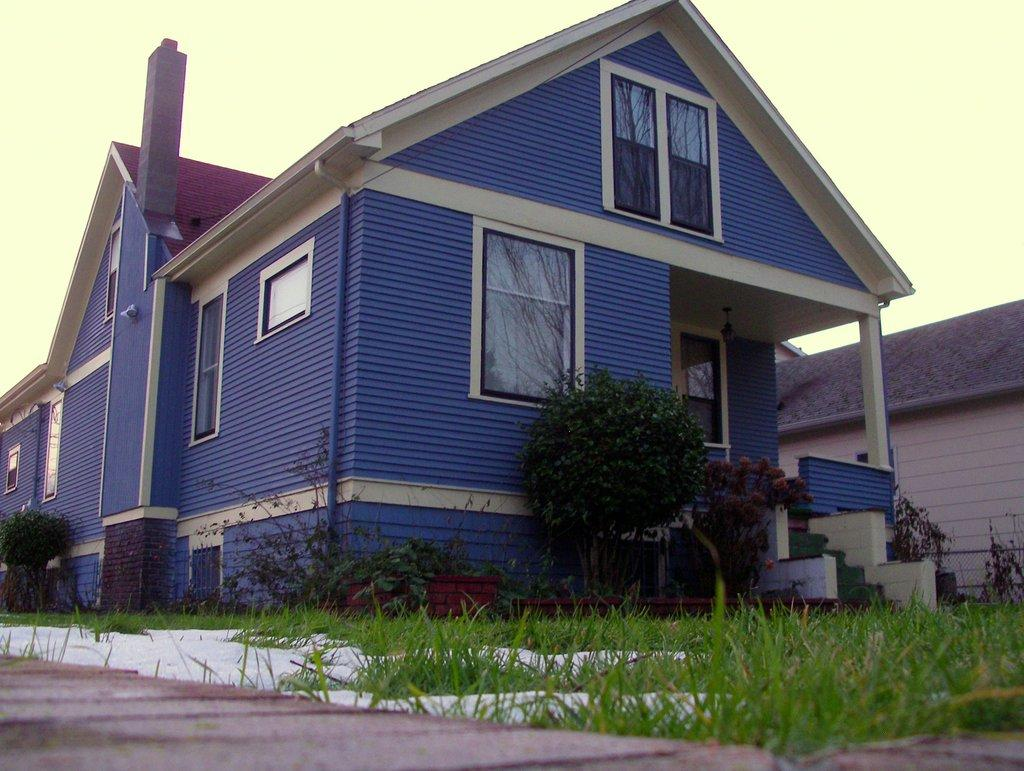What type of structures can be seen in the image? There are roofs of houses in the image. What architectural feature is present in the image? There are stairs in the image. What type of vegetation is visible in the image? There is grass and plants in the image. What type of surface is present in the image? There is a path in the image. What is visible in the background of the image? The sky is visible in the background of the image. What color is the ink spilled on the path in the image? There is no ink spilled on the path in the image. How many baskets are hanging from the plants in the image? There are no baskets hanging from the plants in the image. 